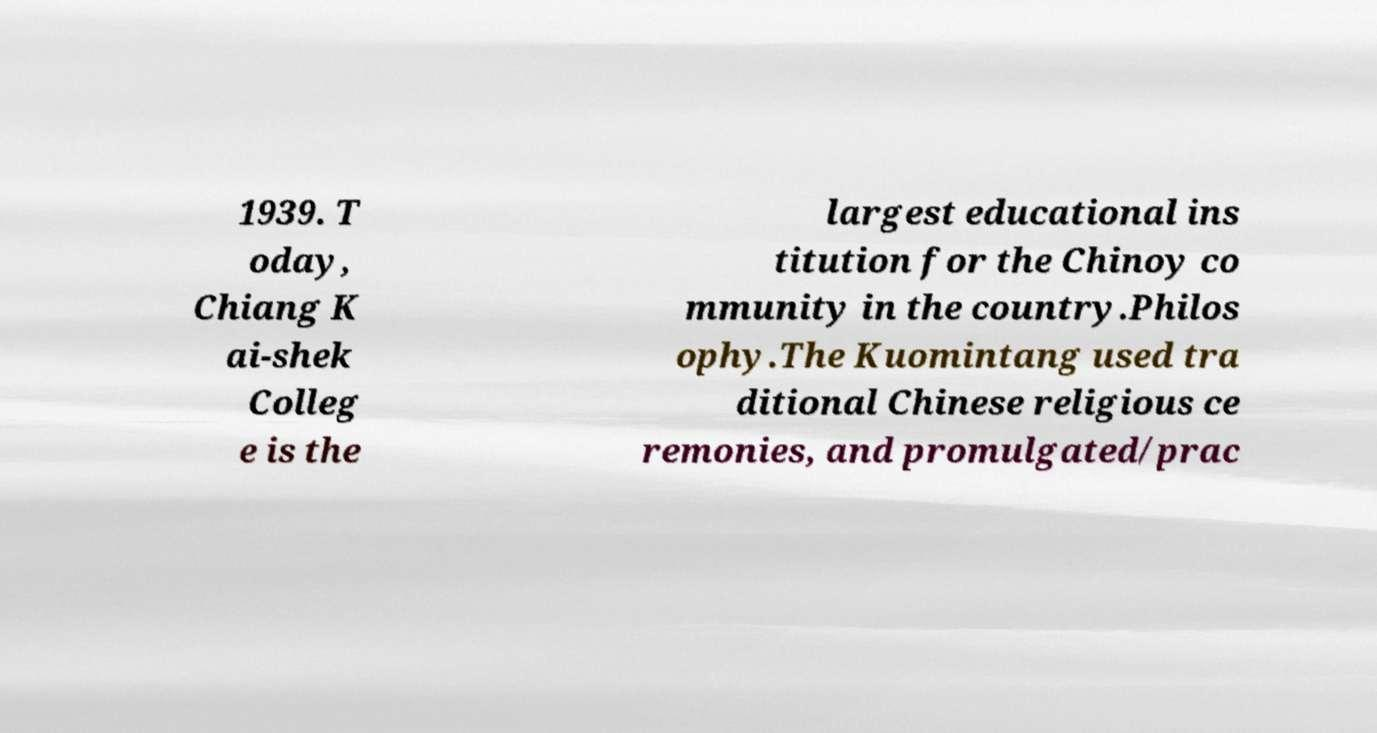Could you extract and type out the text from this image? 1939. T oday, Chiang K ai-shek Colleg e is the largest educational ins titution for the Chinoy co mmunity in the country.Philos ophy.The Kuomintang used tra ditional Chinese religious ce remonies, and promulgated/prac 